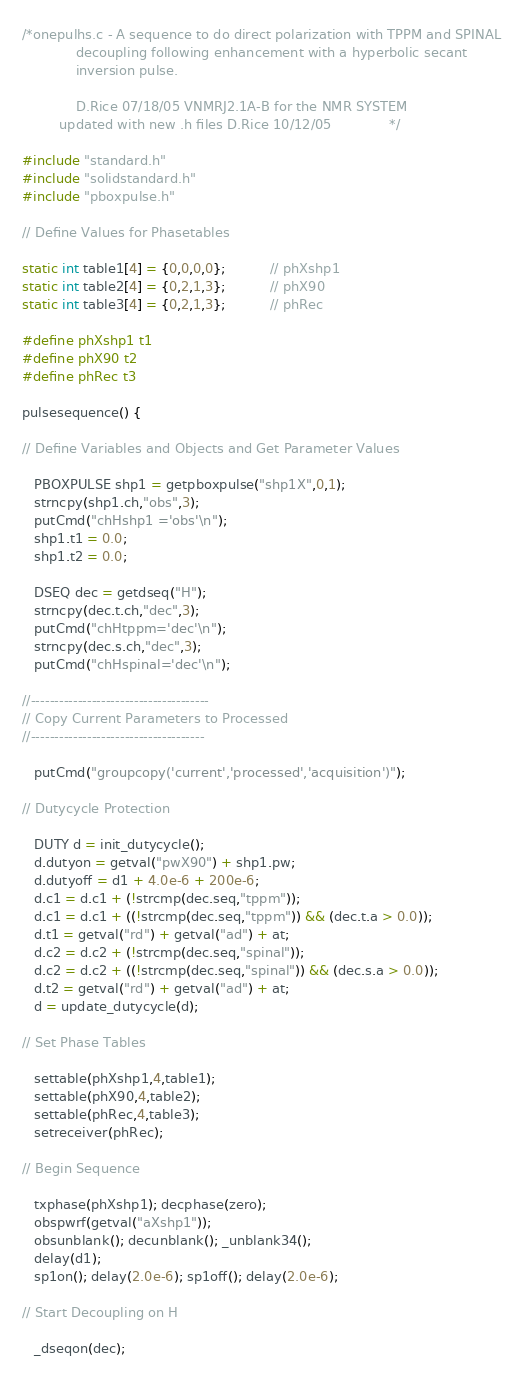Convert code to text. <code><loc_0><loc_0><loc_500><loc_500><_C_>/*onepulhs.c - A sequence to do direct polarization with TPPM and SPINAL
             decoupling following enhancement with a hyperbolic secant 
             inversion pulse.

             D.Rice 07/18/05 VNMRJ2.1A-B for the NMR SYSTEM
	     updated with new .h files D.Rice 10/12/05              */

#include "standard.h"
#include "solidstandard.h"
#include "pboxpulse.h"

// Define Values for Phasetables

static int table1[4] = {0,0,0,0};           // phXshp1
static int table2[4] = {0,2,1,3};           // phX90
static int table3[4] = {0,2,1,3};           // phRec

#define phXshp1 t1
#define phX90 t2
#define phRec t3

pulsesequence() {

// Define Variables and Objects and Get Parameter Values

   PBOXPULSE shp1 = getpboxpulse("shp1X",0,1);
   strncpy(shp1.ch,"obs",3);
   putCmd("chHshp1 ='obs'\n");
   shp1.t1 = 0.0;
   shp1.t2 = 0.0;

   DSEQ dec = getdseq("H");
   strncpy(dec.t.ch,"dec",3);
   putCmd("chHtppm='dec'\n");
   strncpy(dec.s.ch,"dec",3);
   putCmd("chHspinal='dec'\n");

//--------------------------------------
// Copy Current Parameters to Processed
//-------------------------------------

   putCmd("groupcopy('current','processed','acquisition')");

// Dutycycle Protection

   DUTY d = init_dutycycle();
   d.dutyon = getval("pwX90") + shp1.pw;
   d.dutyoff = d1 + 4.0e-6 + 200e-6;
   d.c1 = d.c1 + (!strcmp(dec.seq,"tppm"));
   d.c1 = d.c1 + ((!strcmp(dec.seq,"tppm")) && (dec.t.a > 0.0));
   d.t1 = getval("rd") + getval("ad") + at;
   d.c2 = d.c2 + (!strcmp(dec.seq,"spinal"));
   d.c2 = d.c2 + ((!strcmp(dec.seq,"spinal")) && (dec.s.a > 0.0));
   d.t2 = getval("rd") + getval("ad") + at;
   d = update_dutycycle(d);

// Set Phase Tables

   settable(phXshp1,4,table1);
   settable(phX90,4,table2);
   settable(phRec,4,table3);
   setreceiver(phRec);

// Begin Sequence

   txphase(phXshp1); decphase(zero);
   obspwrf(getval("aXshp1"));
   obsunblank(); decunblank(); _unblank34();
   delay(d1);
   sp1on(); delay(2.0e-6); sp1off(); delay(2.0e-6);

// Start Decoupling on H

   _dseqon(dec);
</code> 